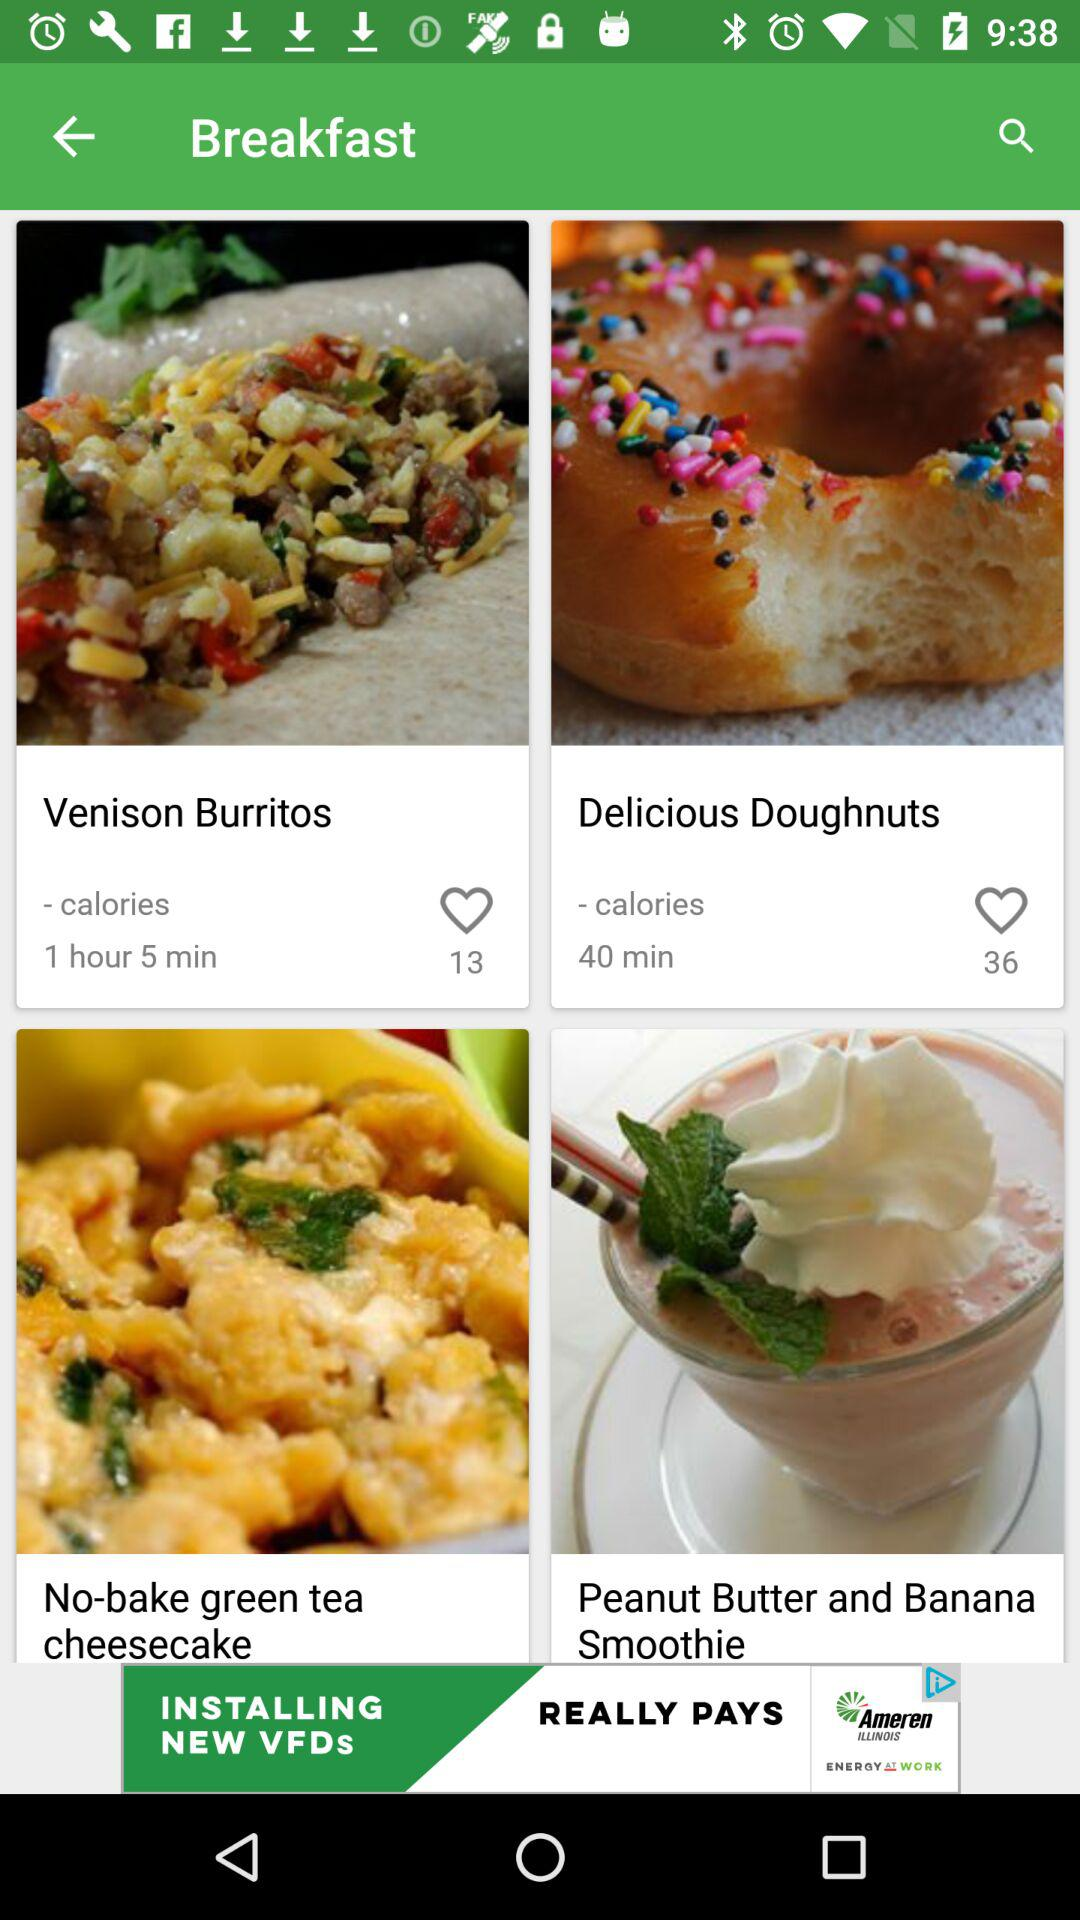How many people have liked "Venison Burritos"? "Venison Burritos" has been liked by 13 people. 